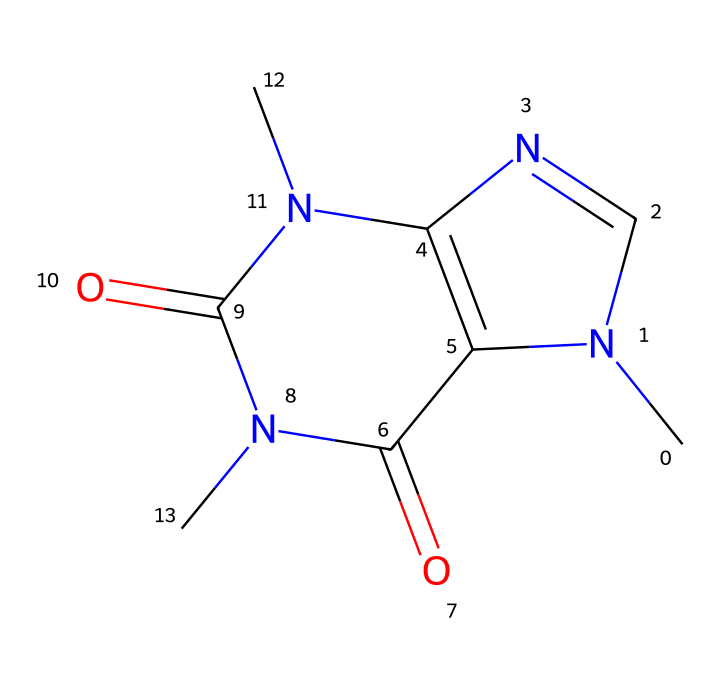What is the molecular formula of caffeine? By analyzing the SMILES representation, we can identify and count the atoms present. The structure contains 8 carbon (C) atoms, 10 hydrogen (H) atoms, 4 nitrogen (N) atoms, and 2 oxygen (O) atoms. Combining these gives us the molecular formula C8H10N4O2.
Answer: C8H10N4O2 How many rings are present in the caffeine structure? The SMILES shows the presence of two cycles in the chemical structure, indicated by the numbers 1 and 2 that denote the ring closure points. This confirms there are two interconnected ring structures.
Answer: 2 What type of functional groups are present in caffeine? From the SMILES, we can observe that caffeine contains carbonyl groups (C=O) and amine groups (N). The presence of these groups classifies caffeine as an amino acid derivative and highlights its properties as a non-electrolyte.
Answer: carbonyl and amine Does caffeine dissociate in water? As a non-electrolyte, caffeine does not dissociate into ions when dissolved in water. Looking at its molecular structure and properties, it retains its molecular integrity in solution without forming charged particles.
Answer: No What is the primary interaction responsible for caffeine's solubility in water? The nitrogen atoms in caffeine can form hydrogen bonds with water molecules, which is a key factor in its solubility. The presence of nitrogen atoms enables these interactions, while the overall non-electrolyte nature allows for the intact presence of the molecule in solution.
Answer: Hydrogen bonding Is caffeine considered a weak or strong base? Based on its structure, caffeine contains nitrogen atoms that can accept protons, making it a weak base in aqueous solution. Its capacity to release or bond to protons is not strong compared to traditional strong bases but does indicate basic properties.
Answer: Weak base 